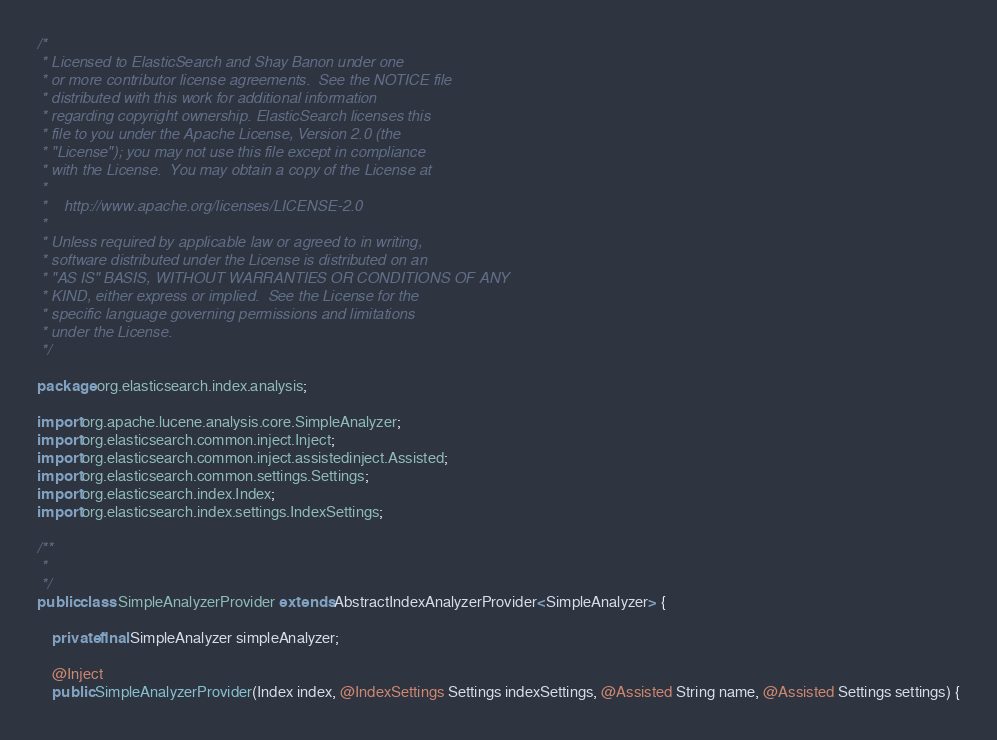<code> <loc_0><loc_0><loc_500><loc_500><_Java_>/*
 * Licensed to ElasticSearch and Shay Banon under one
 * or more contributor license agreements.  See the NOTICE file
 * distributed with this work for additional information
 * regarding copyright ownership. ElasticSearch licenses this
 * file to you under the Apache License, Version 2.0 (the
 * "License"); you may not use this file except in compliance
 * with the License.  You may obtain a copy of the License at
 *
 *    http://www.apache.org/licenses/LICENSE-2.0
 *
 * Unless required by applicable law or agreed to in writing,
 * software distributed under the License is distributed on an
 * "AS IS" BASIS, WITHOUT WARRANTIES OR CONDITIONS OF ANY
 * KIND, either express or implied.  See the License for the
 * specific language governing permissions and limitations
 * under the License.
 */

package org.elasticsearch.index.analysis;

import org.apache.lucene.analysis.core.SimpleAnalyzer;
import org.elasticsearch.common.inject.Inject;
import org.elasticsearch.common.inject.assistedinject.Assisted;
import org.elasticsearch.common.settings.Settings;
import org.elasticsearch.index.Index;
import org.elasticsearch.index.settings.IndexSettings;

/**
 *
 */
public class SimpleAnalyzerProvider extends AbstractIndexAnalyzerProvider<SimpleAnalyzer> {

    private final SimpleAnalyzer simpleAnalyzer;

    @Inject
    public SimpleAnalyzerProvider(Index index, @IndexSettings Settings indexSettings, @Assisted String name, @Assisted Settings settings) {</code> 